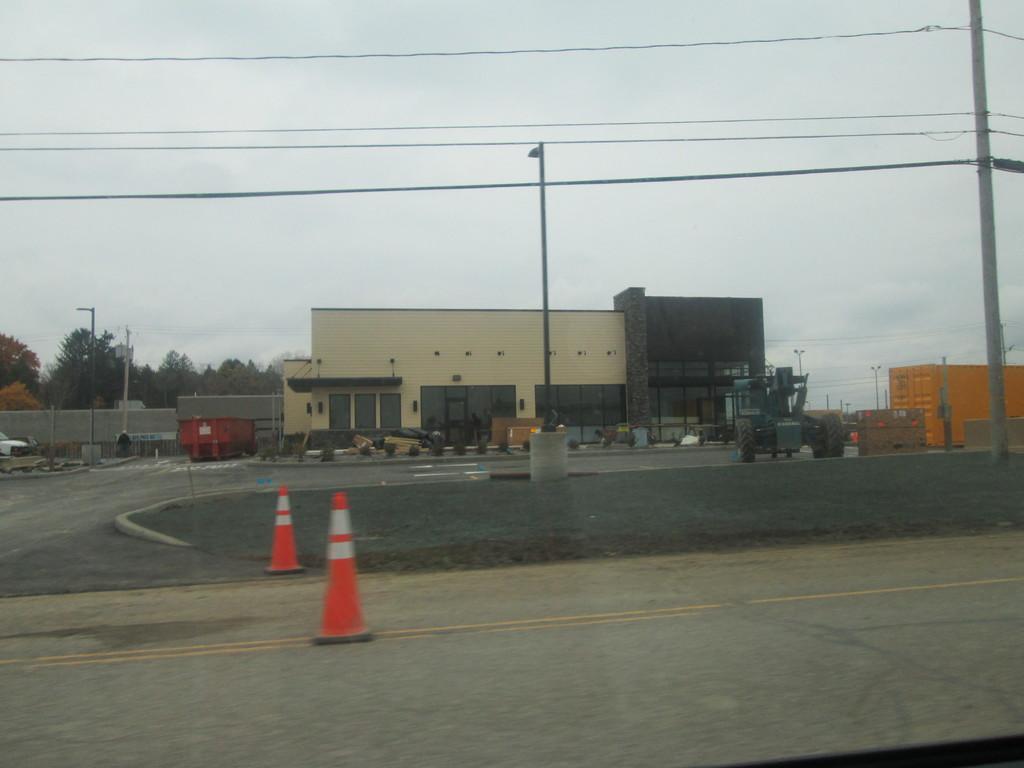Can you describe this image briefly? In this image I can see two traffic poles which are orange and white in color on the road, few poles and few wires. In the background I can see a building, a vehicle, few wires, a orange colored building, few trees, few poles and the sky. 